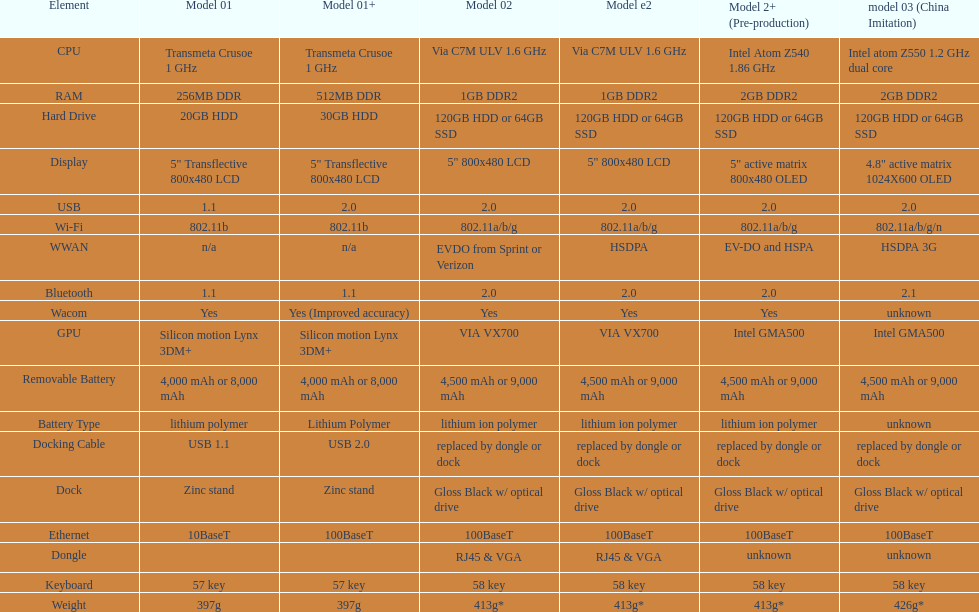What is the total number of components on the chart? 18. 